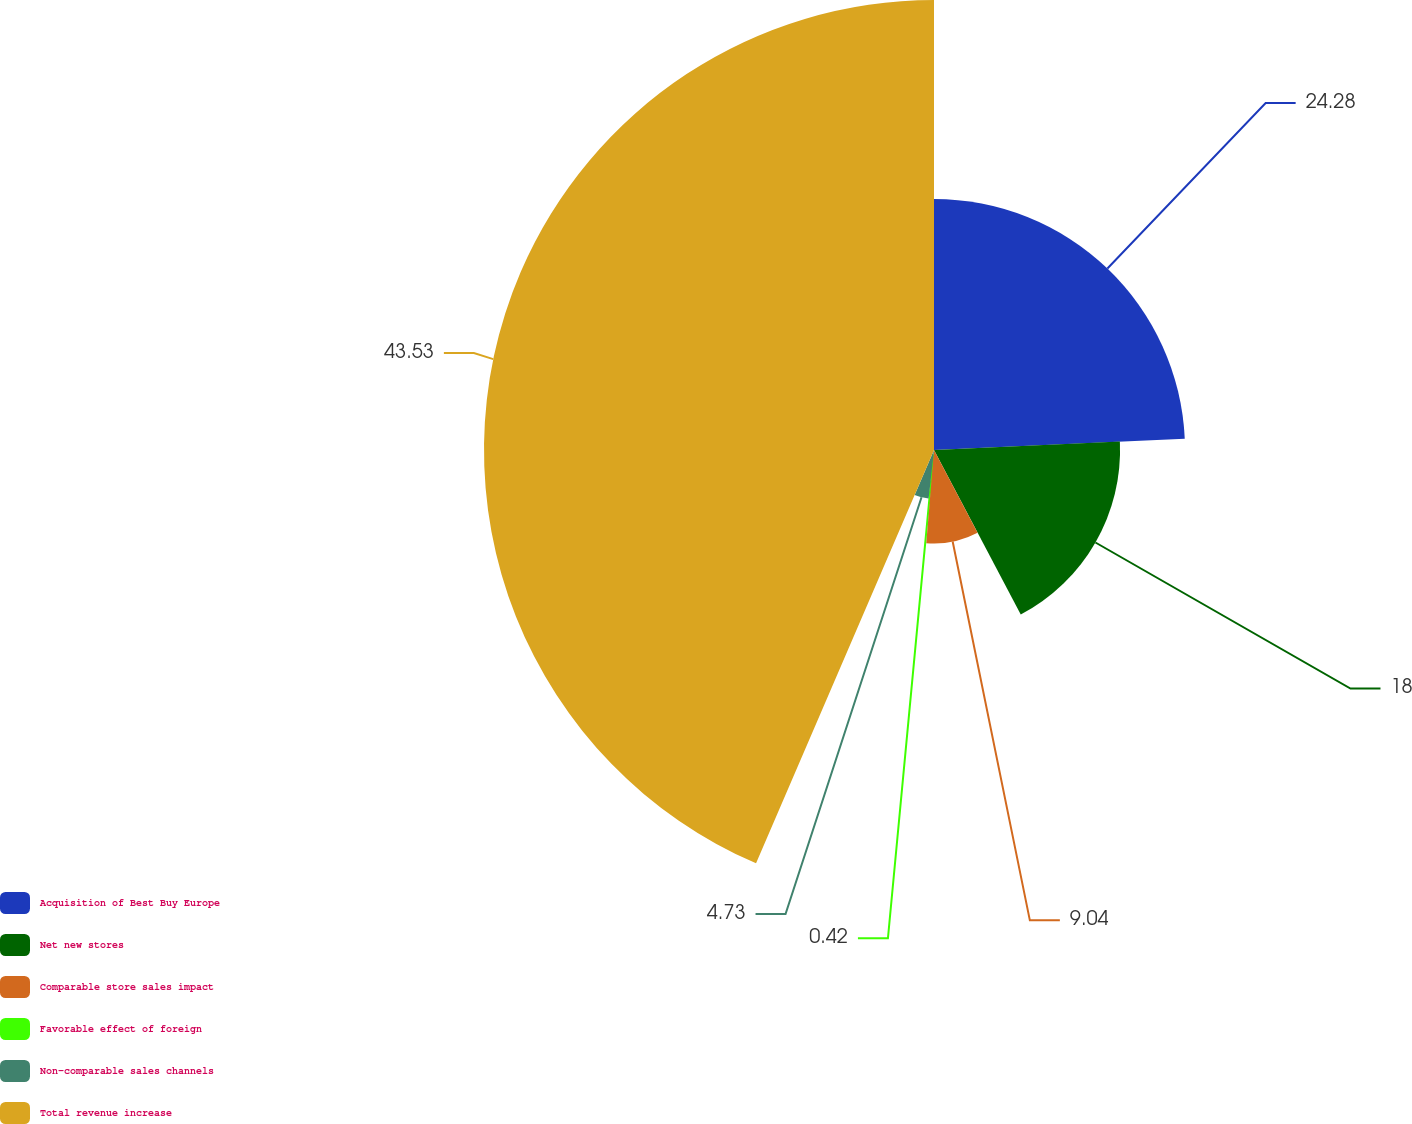Convert chart. <chart><loc_0><loc_0><loc_500><loc_500><pie_chart><fcel>Acquisition of Best Buy Europe<fcel>Net new stores<fcel>Comparable store sales impact<fcel>Favorable effect of foreign<fcel>Non-comparable sales channels<fcel>Total revenue increase<nl><fcel>24.28%<fcel>18.0%<fcel>9.04%<fcel>0.42%<fcel>4.73%<fcel>43.53%<nl></chart> 